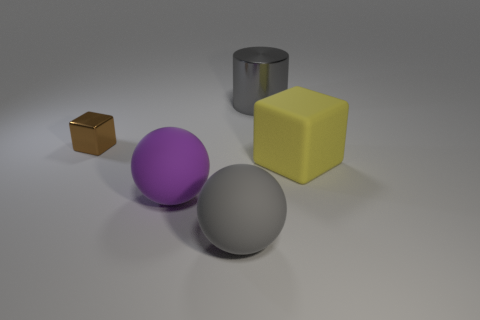Is there anything else that is the same size as the brown thing?
Provide a succinct answer. No. Are there any other things that are the same shape as the large metal thing?
Give a very brief answer. No. There is a gray shiny cylinder; what number of big yellow things are in front of it?
Keep it short and to the point. 1. Are there an equal number of small brown cubes on the right side of the big purple ball and yellow objects?
Offer a very short reply. No. Do the large yellow block and the small block have the same material?
Your response must be concise. No. There is a object that is both left of the gray shiny thing and behind the purple object; what size is it?
Provide a succinct answer. Small. What number of gray matte things are the same size as the purple rubber sphere?
Your answer should be compact. 1. What is the size of the cube to the left of the big matte object that is behind the big purple matte sphere?
Provide a succinct answer. Small. Is the shape of the large gray object in front of the small shiny block the same as the large matte object to the left of the gray matte ball?
Keep it short and to the point. Yes. There is a large object that is on the left side of the yellow thing and behind the purple matte sphere; what color is it?
Your answer should be very brief. Gray. 